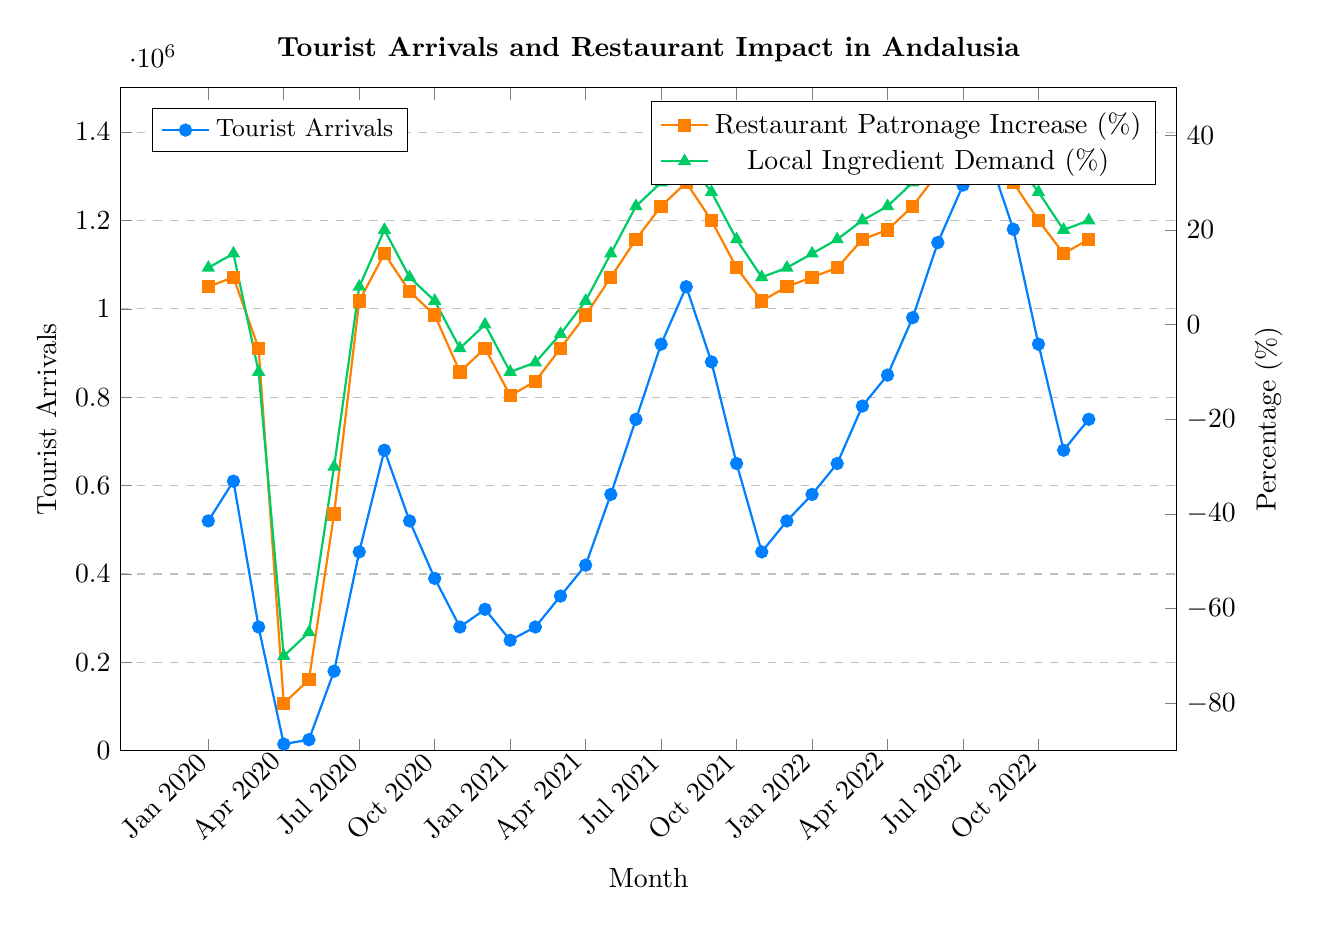Which year had the lowest tourist arrivals in March? By observing the tourist arrivals in March across the three years (2020, 2021, and 2022), we need to compare the values. For March 2020, the tourist arrivals were 280,000; for March 2021, it was 350,000; and for March 2022, it was 780,000. The lowest is in 2020.
Answer: 2020 How did restaurant patronage change from May 2021 to June 2021? In May 2021, the restaurant patronage increase was 10%, and in June 2021, it was 18%. To find the change, we subtract the May value from the June value: 18 - 10 = 8%.
Answer: 8% Which month in 2022 saw the highest tourist arrivals? To find the month with the highest arrivals in 2022, observe the data points from January to December 2022. The highest value is 1,350,000 in August.
Answer: August What is the average local ingredient demand increase (%) for July across the three years? For July, the local ingredient demand percentages are 8% (2020), 30% (2021), and 42% (2022). Sum these values: 8 + 30 + 42 = 80. Divide by the number of years, 80 / 3 = ~26.7%.
Answer: ~26.7% During which month in 2020 did the restaurant patronage see the most significant decrease? Observing the restaurant patronage values for each month in 2020, the most significant decrease is in April with -80%.
Answer: April Compare the tourist arrivals in June across the three years and identify the year with the highest increase. The tourist arrivals in June were 180,000 (2020), 750,000 (2021), and 1,150,000 (2022). The highest increase occurred from 2020 to 2021: 750,000 - 180,000 = 570,000.
Answer: 2022 What trend is observed in local ingredient demand from April to August 2022? From April to August 2022, local ingredient demand percentages are 25%, 30%, 38%, 42%, and 45%, respectively. There is a consistent increasing trend.
Answer: Increasing How did the local ingredient demand percentage in October 2022 compare to that in October 2021? In October 2021, local ingredient demand was 18%. In October 2022, it was 28%. The demand increased by 28 - 18 = 10%.
Answer: Increased by 10% Identify the month with the highest tourist arrivals in the entire data set and state its value. Observing all the months, the highest tourist arrivals were in August 2022, with a value of 1,350,000.
Answer: August 2022, 1,350,000 